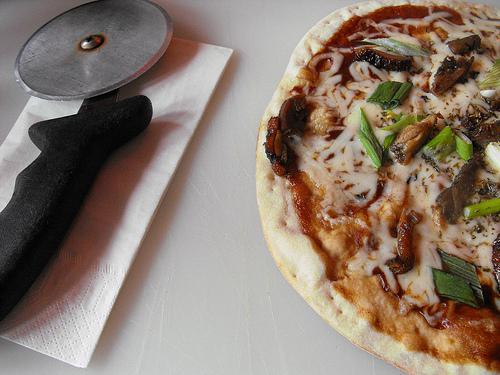Question: what kind of food is in the photo?
Choices:
A. Shrimp.
B. Pizza.
C. French fries.
D. Strawberries.
Answer with the letter. Answer: B Question: what color are the vegetables on the pizza?
Choices:
A. Red.
B. Green.
C. Yellow.
D. Black.
Answer with the letter. Answer: B Question: what is under the pizza wheel?
Choices:
A. Table.
B. Oven.
C. Napkin.
D. Counter top.
Answer with the letter. Answer: C 